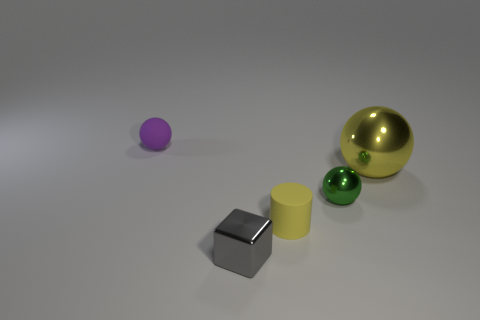Is there a tiny yellow cylinder behind the tiny matte thing that is on the right side of the sphere behind the yellow metallic thing?
Give a very brief answer. No. The tiny green metallic object is what shape?
Your response must be concise. Sphere. Are there fewer gray blocks behind the tiny gray shiny thing than shiny spheres?
Your answer should be compact. Yes. Is there a small green metal thing of the same shape as the large yellow object?
Offer a very short reply. Yes. There is a yellow matte object that is the same size as the block; what shape is it?
Ensure brevity in your answer.  Cylinder. What number of objects are purple shiny cylinders or yellow objects?
Your answer should be very brief. 2. Is there a large red metallic cylinder?
Provide a succinct answer. No. Is the number of small green metallic blocks less than the number of tiny cylinders?
Make the answer very short. Yes. Is there a cyan matte thing of the same size as the yellow metallic sphere?
Your answer should be compact. No. There is a small yellow thing; is it the same shape as the rubber object behind the yellow rubber object?
Your response must be concise. No. 